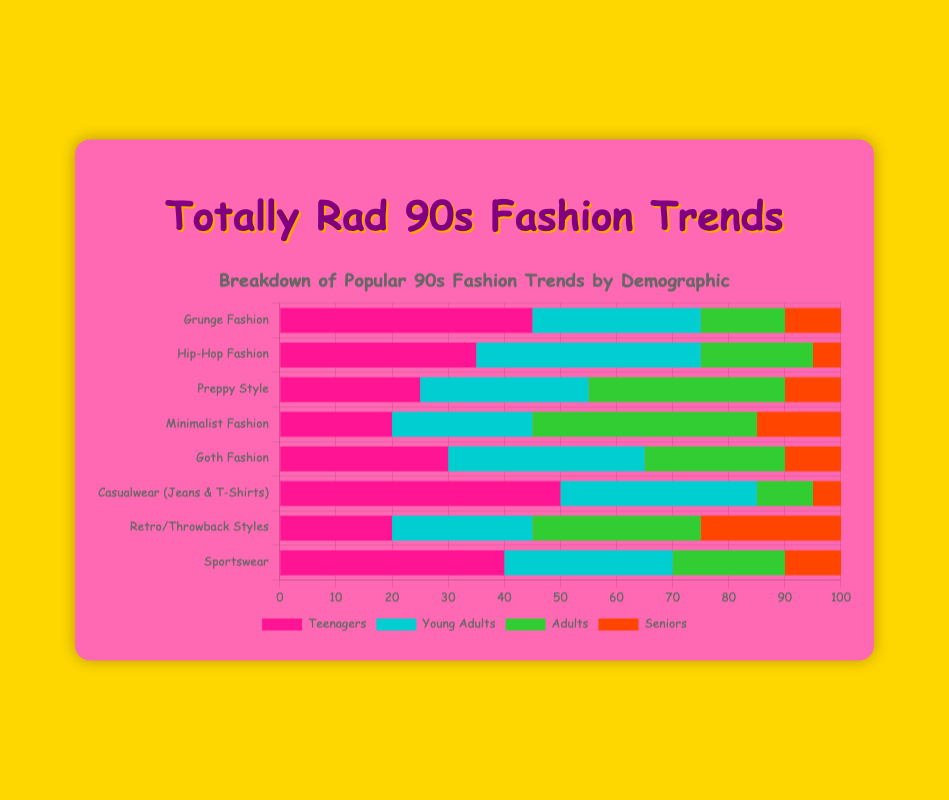what demographic shows the highest interest in Casualwear (Jeans & T-Shirts)? Look for the highest bar for "Casualwear (Jeans & T-Shirts)" and identify the demographic it represents. For Casualwear, the Teenagers' bar is the highest with a value of 50.
Answer: Teenagers Which fashion trend is the least popular among Seniors? Compare all the bars representing Seniors' data points across different trends. The smallest bar for Seniors is for "Hip-Hop Fashion", which has a value of 5.
Answer: Hip-Hop Fashion How many more Teenagers prefer Grunge Fashion compared to Seniors? Find the values for Teenagers and Seniors in the Grunge Fashion category and subtract the Senior value (10) from the Teenager value (45). The difference is 45 - 10 = 35.
Answer: 35 What is the total interest in Minimalist Fashion across all demographics? Sum the values for Minimalist Fashion across all demographics (20 + 25 + 40 + 15). The total is 100.
Answer: 100 Which demographic has the highest overall interest across all fashion trends? Sum up the values for all trends for each demographic and compare the sums. Add Teenagers (45 + 35 + 25 + 20 + 30 + 50 + 20 + 40 = 265), Young Adults (30 + 40 + 30 + 25 + 35 + 35 + 25 + 30 = 250), Adults (15 + 20 + 35 + 40 + 25 + 10 + 30 + 20 = 195), and Seniors (10 + 5 + 10 + 15 + 10 + 5 + 25 + 10 = 90). The highest total is for Teenagers.
Answer: Teenagers For Young Adults, which trend is twice as popular as Retro/Throwback Styles? Determine the value for Young Adults in Retro/Throwback Styles (25) and look for the trend in Young Adults that has double this value (25 * 2 = 50). No trend matches exactly, but "Hip-Hop Fashion" comes closest with a value of 40.
Answer: Hip-Hop Fashion How many trends have more than 30% interest among Young Adults? Check the values for Young Adults across all trends and count the ones greater than 30. The trends are "Grunge Fashion" (30), "Hip-Hop Fashion" (40), "Preppy Style" (30), "Goth Fashion" (35), and "Sportswear" (30). There are 5 trends.
Answer: 5 Among adults, which fashion trend shows a growing trend starting from Teenagers to Seniors? Compare the values of each demographic for each trend to see which trend increases from Teenagers to Seniors. One trend where values grow is "Minimalist Fashion": Teenagers (20), Young Adults (25), Adults (40), Seniors (15).
Answer: Minimalist Fashion 